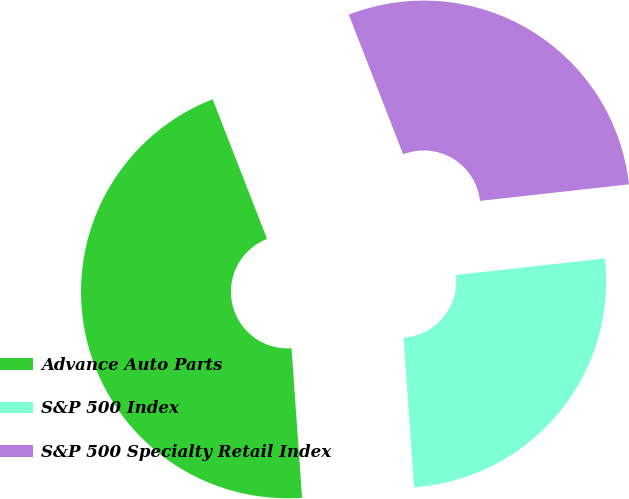<chart> <loc_0><loc_0><loc_500><loc_500><pie_chart><fcel>Advance Auto Parts<fcel>S&P 500 Index<fcel>S&P 500 Specialty Retail Index<nl><fcel>45.21%<fcel>25.64%<fcel>29.15%<nl></chart> 